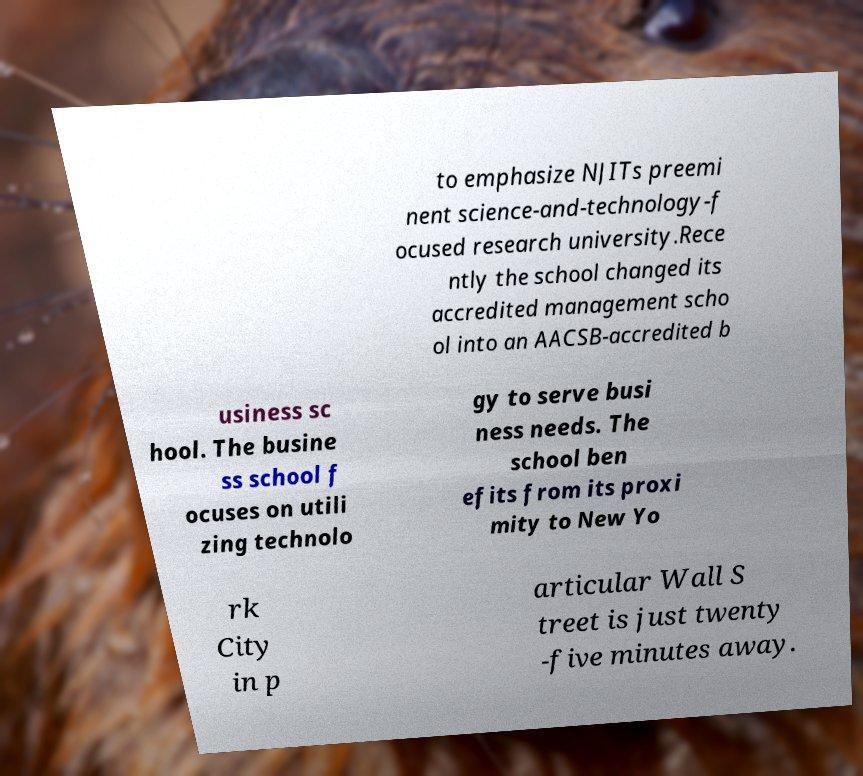What messages or text are displayed in this image? I need them in a readable, typed format. to emphasize NJITs preemi nent science-and-technology-f ocused research university.Rece ntly the school changed its accredited management scho ol into an AACSB-accredited b usiness sc hool. The busine ss school f ocuses on utili zing technolo gy to serve busi ness needs. The school ben efits from its proxi mity to New Yo rk City in p articular Wall S treet is just twenty -five minutes away. 